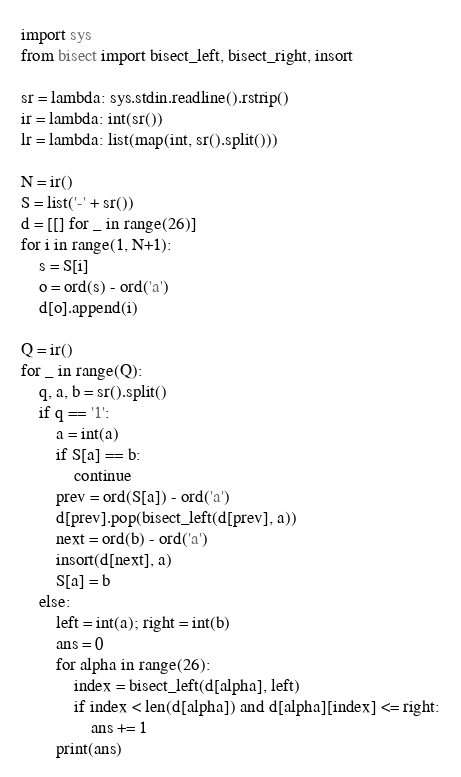Convert code to text. <code><loc_0><loc_0><loc_500><loc_500><_Python_>import sys
from bisect import bisect_left, bisect_right, insort

sr = lambda: sys.stdin.readline().rstrip()
ir = lambda: int(sr())
lr = lambda: list(map(int, sr().split()))

N = ir()
S = list('-' + sr())
d = [[] for _ in range(26)]
for i in range(1, N+1):
    s = S[i]
    o = ord(s) - ord('a')
    d[o].append(i)

Q = ir()
for _ in range(Q):
    q, a, b = sr().split()
    if q == '1':
        a = int(a)
        if S[a] == b:
            continue
        prev = ord(S[a]) - ord('a')
        d[prev].pop(bisect_left(d[prev], a))
        next = ord(b) - ord('a')
        insort(d[next], a)
        S[a] = b
    else:
        left = int(a); right = int(b)
        ans = 0
        for alpha in range(26):
            index = bisect_left(d[alpha], left)
            if index < len(d[alpha]) and d[alpha][index] <= right:
                ans += 1
        print(ans)
</code> 